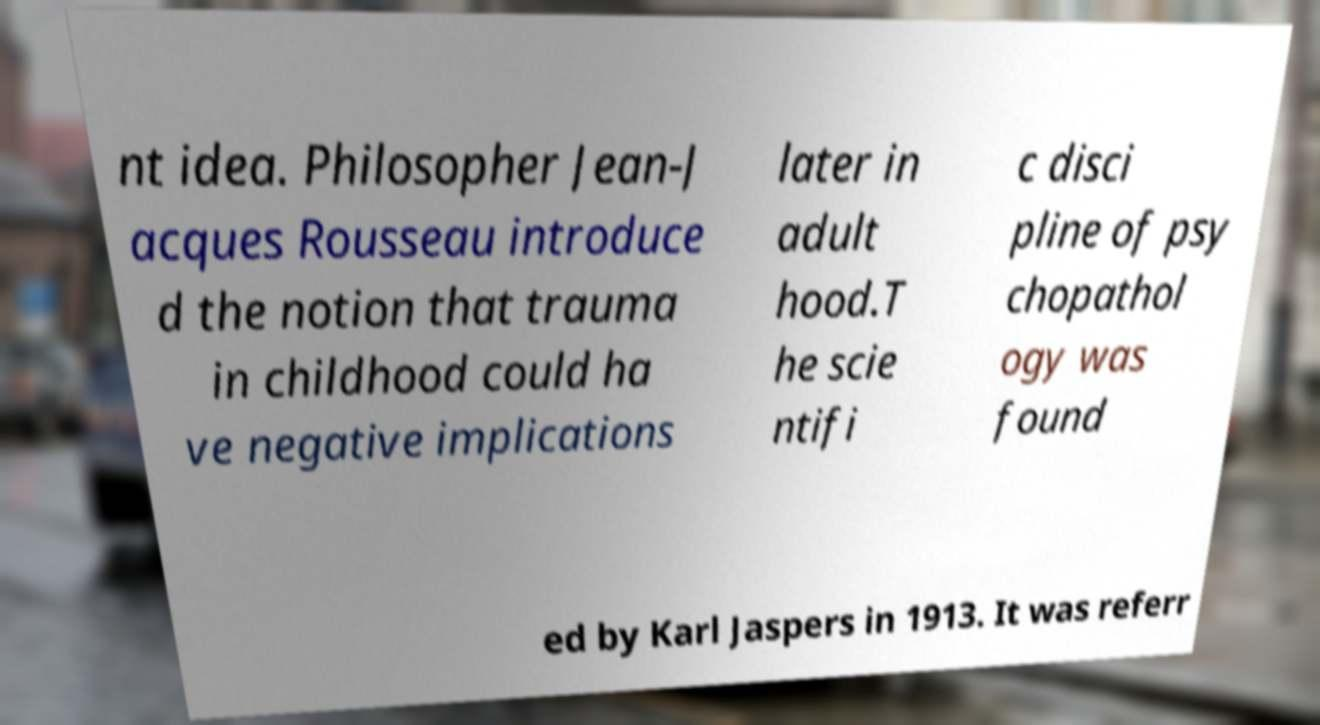Please read and relay the text visible in this image. What does it say? nt idea. Philosopher Jean-J acques Rousseau introduce d the notion that trauma in childhood could ha ve negative implications later in adult hood.T he scie ntifi c disci pline of psy chopathol ogy was found ed by Karl Jaspers in 1913. It was referr 